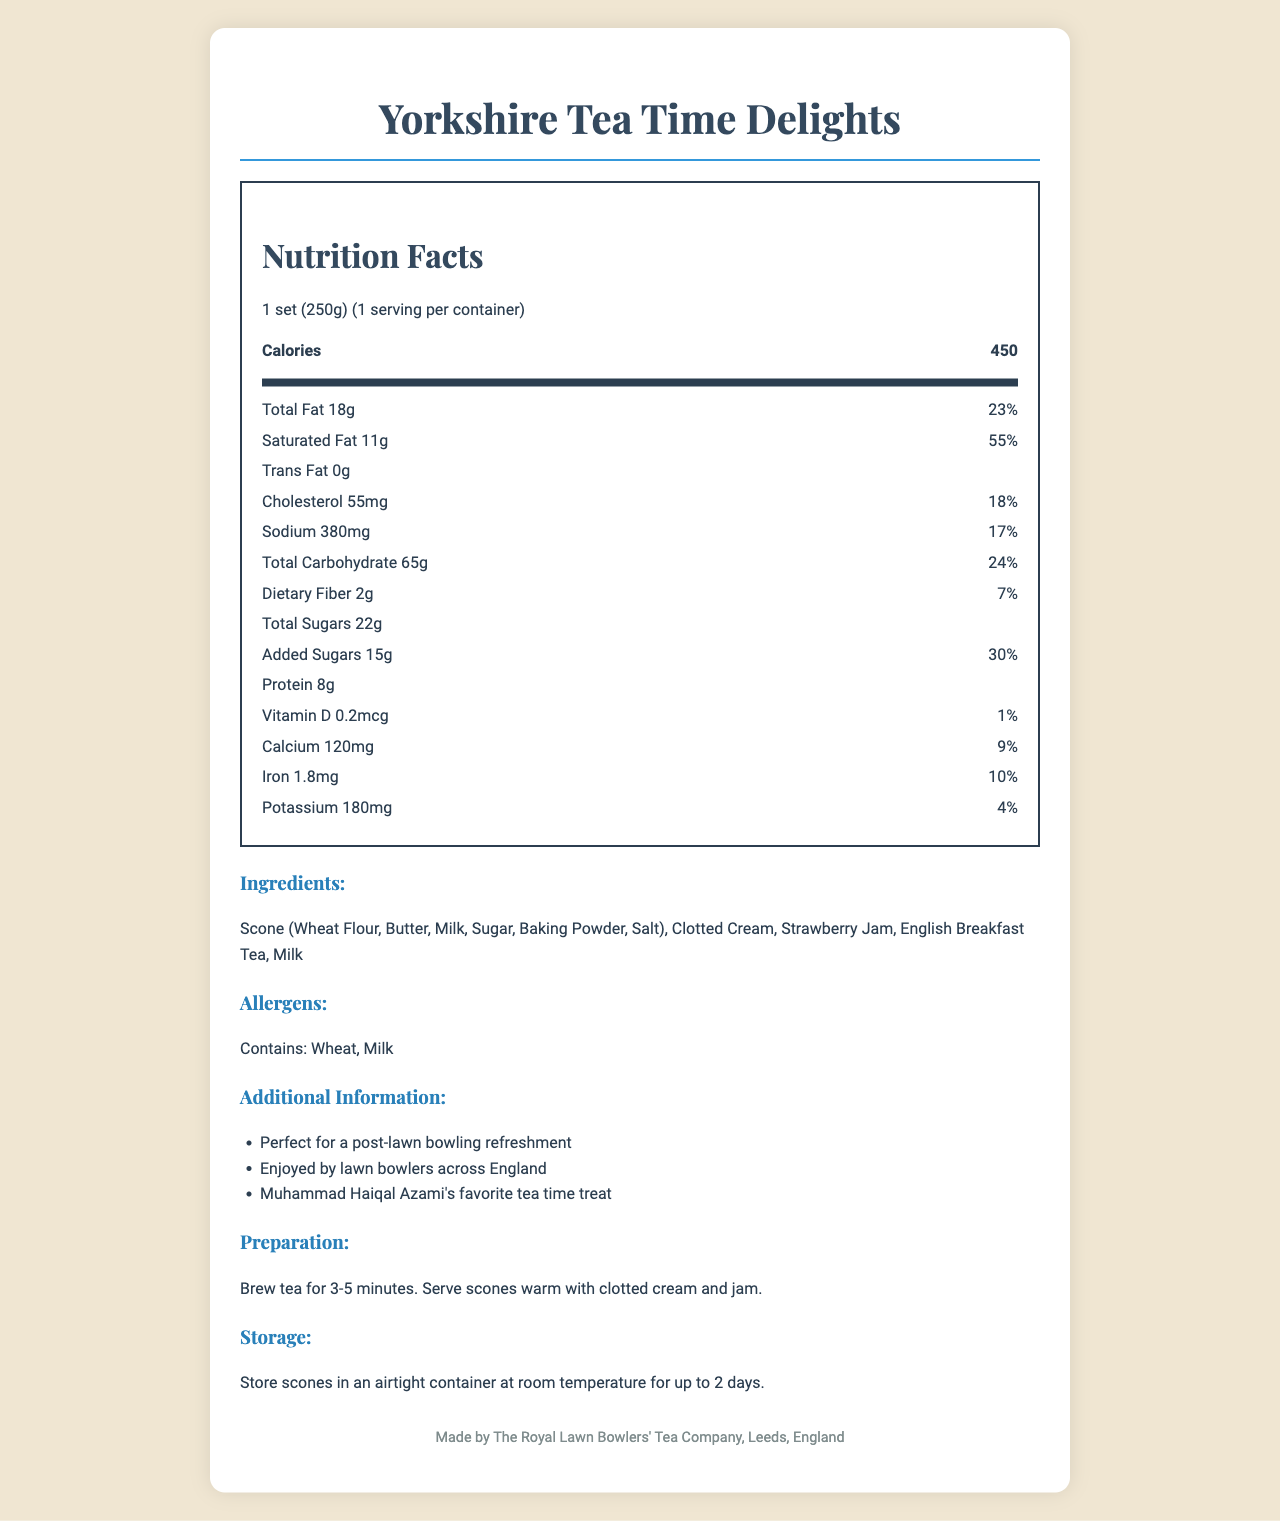what is the serving size? The serving size is clearly listed as "1 set (250g)" at the top of the document.
Answer: 1 set (250g) how many calories are in one serving? The document states that there are 450 calories in one serving.
Answer: 450 what is the total fat content and its daily value percentage? The document specifies that the total fat content is 18 grams and its daily value percentage is 23%.
Answer: 18g and 23% how much added sugar does this set contain? The document indicates that there are 15 grams of added sugars in the tea and scones set.
Answer: 15g can you name two allergens mentioned in the label? The allergens section lists "Contains: Wheat, Milk."
Answer: Wheat, Milk what is the recommended storage method for the scones? The storage instructions state that scones should be stored in an airtight container at room temperature for up to 2 days.
Answer: Store scones in an airtight container at room temperature for up to 2 days how should the tea be prepared? The preparation details specify to brew the tea for 3-5 minutes and serve the scones warm with clotted cream and jam.
Answer: Brew tea for 3-5 minutes. Serve scones warm with clotted cream and jam. what is Muhammad Haiqal Azami's favorite tea time treat? The additional information mentions that this is Muhammad Haiqal Azami's favorite tea time treat.
Answer: Traditional English tea and scones set what is the protein content in one serving? The document lists the protein content as 8 grams per serving.
Answer: 8g who is the manufacturer? The footer of the document states the manufacturer information.
Answer: The Royal Lawn Bowlers' Tea Company, Leeds, England what is the daily value percentage of dietary fiber in one serving? The document indicates that the daily value percentage of dietary fiber is 7%.
Answer: 7% what are all the ingredients used in this tea and scones set? A. Wheat Flour, Butter, Milk, Sugar, Baking Powder, Salt B. Scone (Wheat Flour, Butter, Milk, Sugar, Baking Powder, Salt), Clotted Cream, Strawberry Jam, English Breakfast Tea, Milk C. Flour, Butter, Milk, Sugar, Baking Soda, Salt The ingredients section lists all ingredients as "Scone (Wheat Flour, Butter, Milk, Sugar, Baking Powder, Salt), Clotted Cream, Strawberry Jam, English Breakfast Tea, Milk."
Answer: B which nutrient has the highest daily value percentage? A. Total Fat B. Saturated Fat C. Sodium The document indicates that saturated fat has a daily value percentage of 55%, higher than total fat (23%) and sodium (17%).
Answer: B is this traditional English tea and scones set a good source of Vitamin D? The daily value percentage for Vitamin D is only 1%, indicating it is not a significant source.
Answer: No can you summarize the main nutritional content and additional information of this tea and scones set? The document provides detailed nutritional information about the tea and scones set, including calorie count and content of various nutrients with their daily value percentages. It lists the ingredients, allergens, storage, and preparation instructions, along with some additional facts that emphasize its popularity among lawn bowlers and Muhammad Haiqal Azami.
Answer: The traditional English tea and scones set (1 serving size = 250g) contains 450 calories. Key nutritional elements include 18g total fat (23% DV), 11g saturated fat (55% DV), 55mg cholesterol (18% DV), 380mg sodium (17% DV), 65g total carbohydrates (24% DV), 2g dietary fiber (7% DV), 22g total sugars, including 15g added sugars (30% DV), 8g protein, and minor amounts of Vitamin D, calcium, iron, and potassium. It consists of scones, clotted cream, strawberry jam, English breakfast tea, and milk, and contains wheat and milk allergens. The product is manufactured by The Royal Lawn Bowlers' Tea Company in Leeds, England, and is a favored treat by Muhammad Haiqal Azami. what is the total amount of potassium in one serving? The document lists the potassium content as 180 milligrams per serving.
Answer: 180mg what percentage of iron's daily value does one serving of this tea and scones set provide? The document states that this serving provides 10% of the daily value for iron.
Answer: 10% what is the amount of vitamin B12 in this product? The document does not provide any information on the vitamin B12 content.
Answer: Cannot be determined 